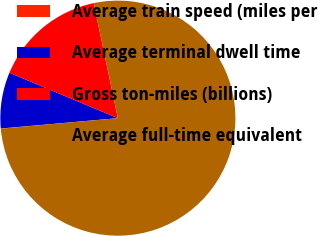<chart> <loc_0><loc_0><loc_500><loc_500><pie_chart><fcel>Average train speed (miles per<fcel>Average terminal dwell time<fcel>Gross ton-miles (billions)<fcel>Average full-time equivalent<nl><fcel>0.03%<fcel>7.71%<fcel>15.4%<fcel>76.86%<nl></chart> 